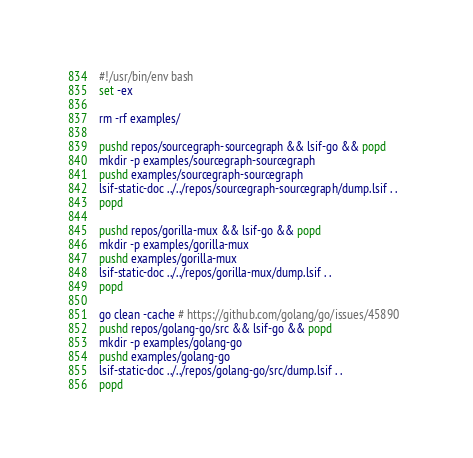Convert code to text. <code><loc_0><loc_0><loc_500><loc_500><_Bash_>#!/usr/bin/env bash
set -ex

rm -rf examples/

pushd repos/sourcegraph-sourcegraph && lsif-go && popd
mkdir -p examples/sourcegraph-sourcegraph
pushd examples/sourcegraph-sourcegraph
lsif-static-doc ../../repos/sourcegraph-sourcegraph/dump.lsif . .
popd

pushd repos/gorilla-mux && lsif-go && popd
mkdir -p examples/gorilla-mux
pushd examples/gorilla-mux
lsif-static-doc ../../repos/gorilla-mux/dump.lsif . .                         
popd

go clean -cache # https://github.com/golang/go/issues/45890
pushd repos/golang-go/src && lsif-go && popd
mkdir -p examples/golang-go
pushd examples/golang-go
lsif-static-doc ../../repos/golang-go/src/dump.lsif . .
popd
</code> 